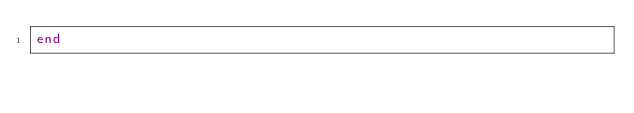<code> <loc_0><loc_0><loc_500><loc_500><_Ruby_>end
</code> 